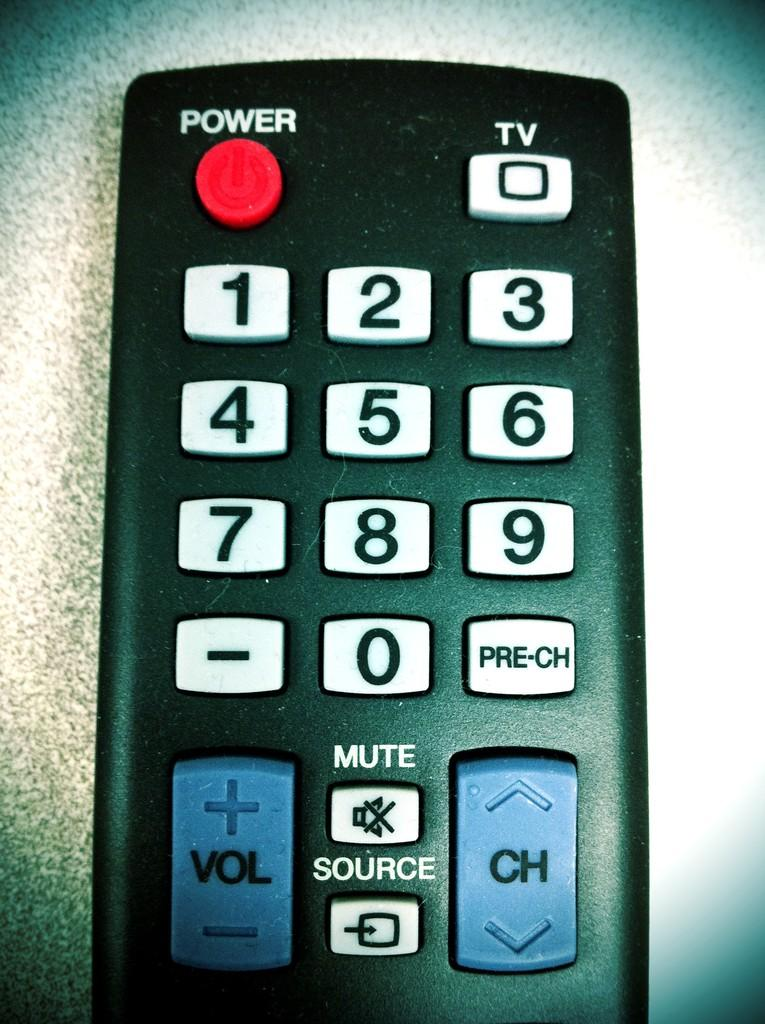<image>
Provide a brief description of the given image. A remote is shown with a power button, TV button, buttons 0-9, Vol, Ch, Mute, Source, and Pre-Ch. 